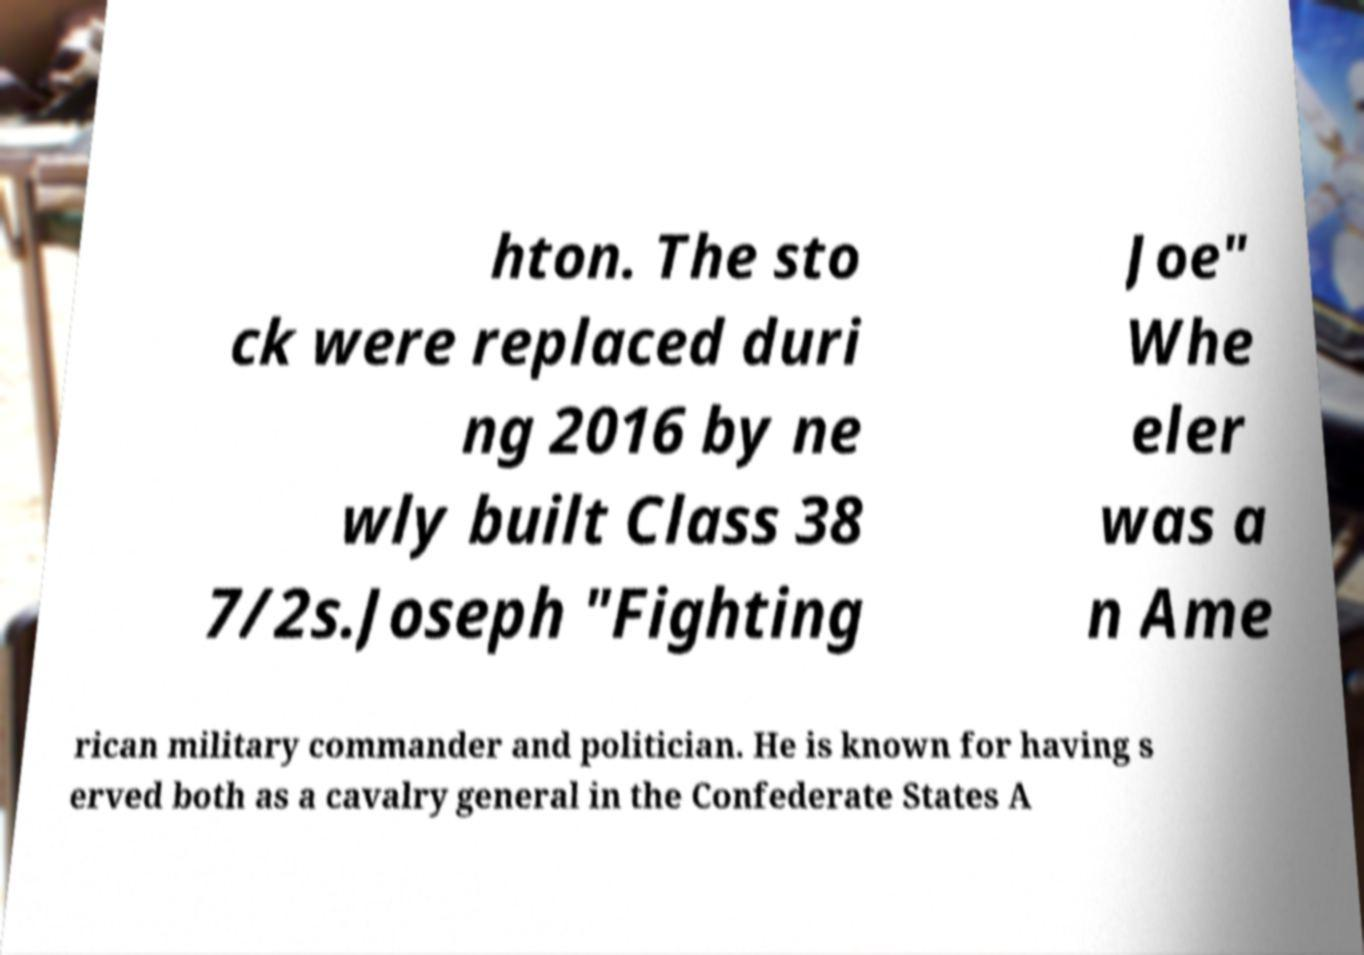I need the written content from this picture converted into text. Can you do that? hton. The sto ck were replaced duri ng 2016 by ne wly built Class 38 7/2s.Joseph "Fighting Joe" Whe eler was a n Ame rican military commander and politician. He is known for having s erved both as a cavalry general in the Confederate States A 